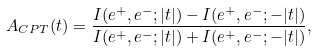<formula> <loc_0><loc_0><loc_500><loc_500>A _ { C P T } ( t ) = \frac { I ( e ^ { + } , e ^ { - } ; | t | ) - I ( e ^ { + } , e ^ { - } ; - | t | ) } { I ( e ^ { + } , e ^ { - } ; | t | ) + I ( e ^ { + } , e ^ { - } ; - | t | ) } ,</formula> 